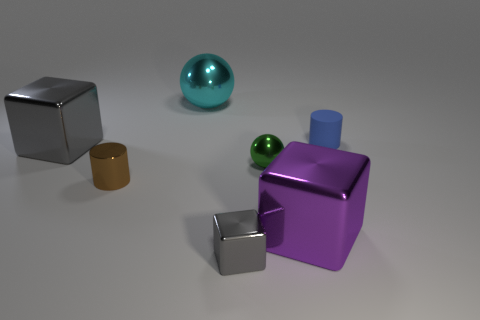Is there anything else that has the same material as the tiny blue cylinder?
Provide a short and direct response. No. How many big objects are the same shape as the tiny gray metallic thing?
Offer a very short reply. 2. There is a cylinder right of the tiny green object; what number of small rubber cylinders are on the right side of it?
Your answer should be compact. 0. How many rubber things are either tiny green balls or blocks?
Ensure brevity in your answer.  0. Is there a small brown thing made of the same material as the tiny blue object?
Provide a short and direct response. No. What number of objects are either things that are left of the tiny shiny cylinder or gray shiny objects that are in front of the small brown metallic thing?
Make the answer very short. 2. Is the color of the shiny cube behind the tiny green sphere the same as the small metal block?
Keep it short and to the point. Yes. What number of other objects are the same color as the big sphere?
Your response must be concise. 0. What is the material of the tiny blue object?
Offer a very short reply. Rubber. Do the cylinder that is on the right side of the cyan metallic object and the cyan metal ball have the same size?
Provide a succinct answer. No. 